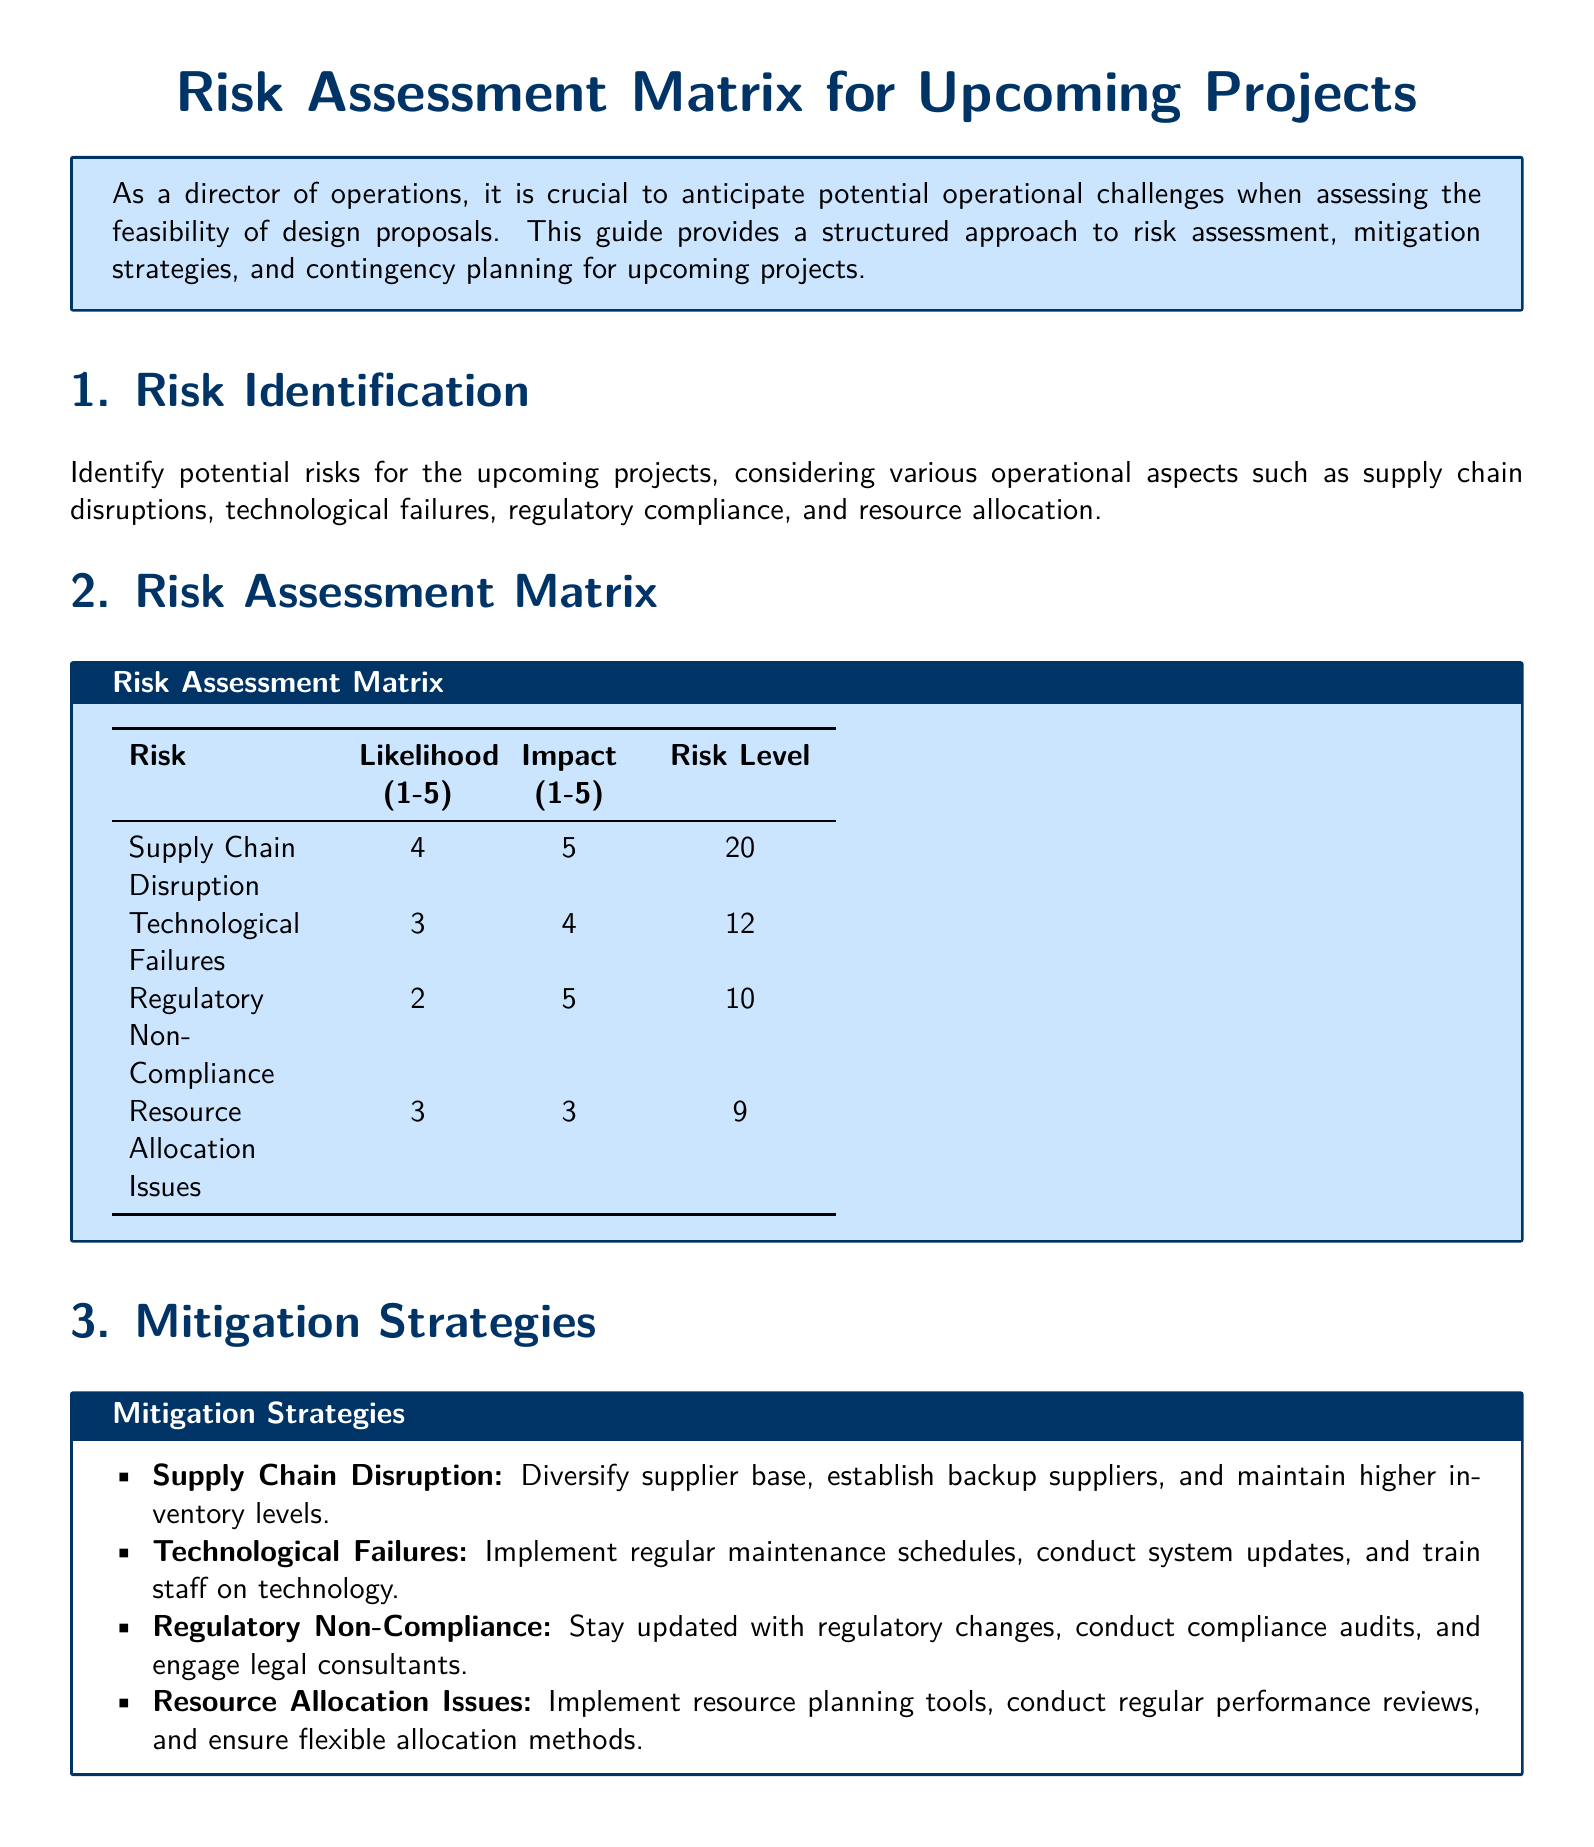What are the potential risks identified for upcoming projects? The document specifies potential risks including supply chain disruptions, technological failures, regulatory non-compliance, and resource allocation issues.
Answer: Supply Chain Disruption, Technological Failures, Regulatory Non-Compliance, Resource Allocation Issues What is the highest risk level in the matrix? The highest risk level in the matrix is determined by the likelihood and impact scores. The highest combination is from supply chain disruption, which has a risk level of 20.
Answer: 20 What is the likelihood of technological failures? The likelihood score for technological failures is explicitly stated in the risk assessment matrix.
Answer: 3 What mitigation strategy is suggested for supply chain disruption? The document mentions specific strategies for mitigating supply chain disruption, including diversifying the supplier base.
Answer: Diversify supplier base What is the contingency plan for regulatory non-compliance? The document lists immediate actions to take in case of regulatory non-compliance, like stopping non-compliant operations.
Answer: Stop non-compliant operations How many total risks are listed in the assessment matrix? The matrix lists four distinct risks, which can be counted directly from the table.
Answer: 4 What is the impact score for resource allocation issues? The impact score for resource allocation issues can be found in the risk assessment matrix.
Answer: 3 What is the document's primary purpose? The document aims to provide a structured approach to risk assessment, including mitigation strategies and contingency plans.
Answer: Risk assessment, mitigation strategies, contingency plans 